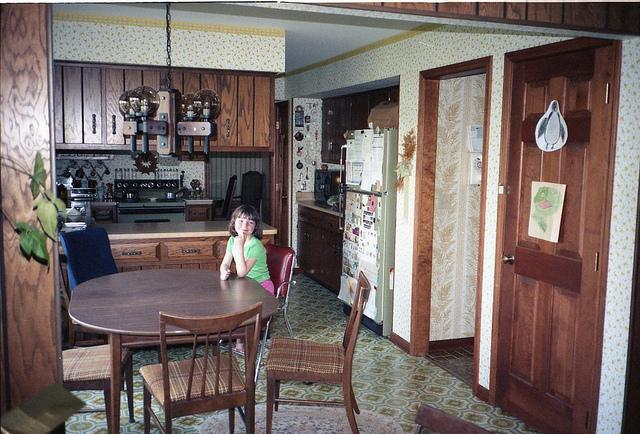In what is the most likely type of structure is this room? kitchen 